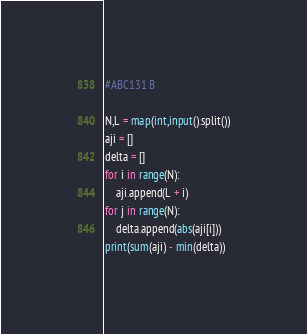Convert code to text. <code><loc_0><loc_0><loc_500><loc_500><_Python_>#ABC131 B

N,L = map(int,input().split())
aji = []
delta = []
for i in range(N):
    aji.append(L + i)
for j in range(N):
    delta.append(abs(aji[i]))
print(sum(aji) - min(delta))</code> 